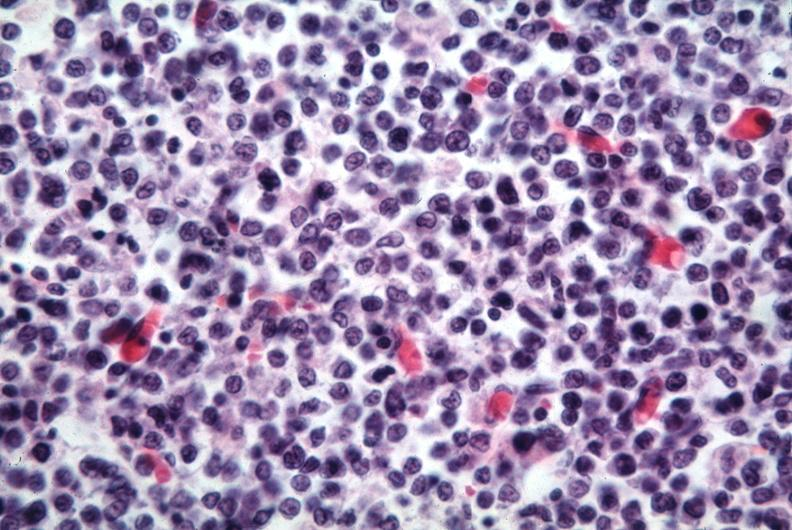what does this image show?
Answer the question using a single word or phrase. Lymphoma cells 